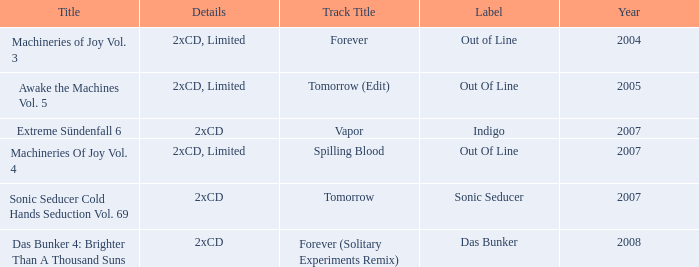Can you provide information about the out of line label and its association with 2005? 2xCD, Limited. 